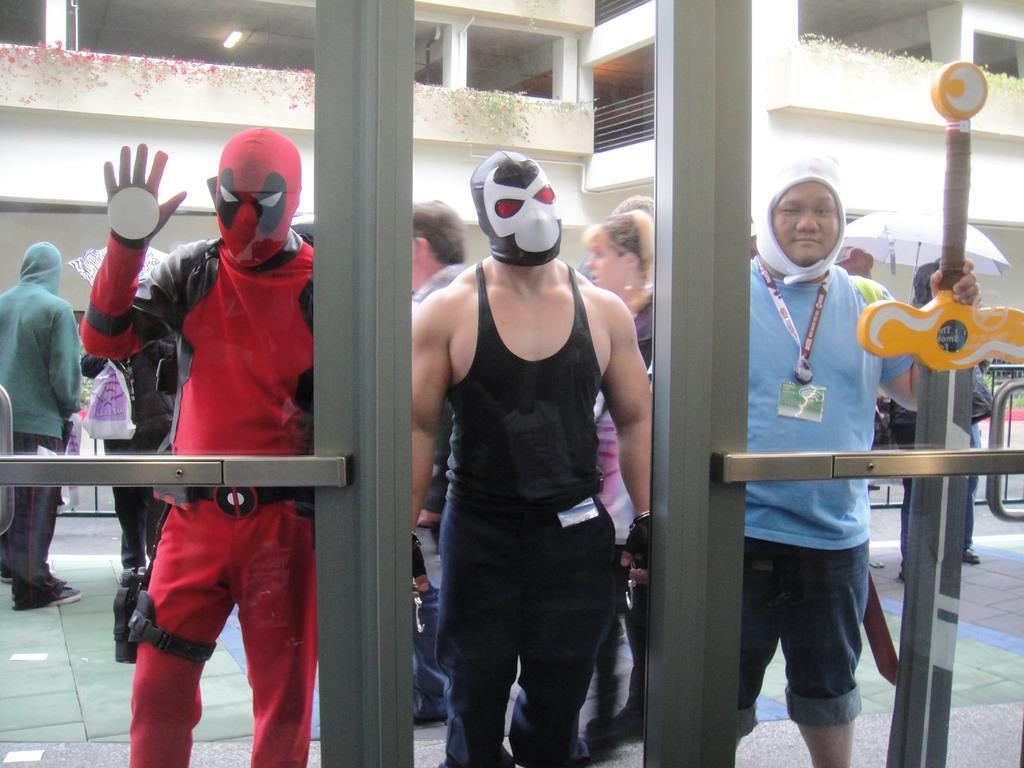How many people are present in the image? There are 3 people in the image. What are the people wearing on their faces? The people are wearing masks. What type of doors can be seen in the image? There are glass doors in the image. Can you describe the background of the image? There are other people visible in the background, and there are buildings in the background. What is the achiever's name in the image? There is no mention of an achiever or a name in the image. Can you tell me how many times the people in the image desire to fly? There is no indication of desire or flying in the image. 